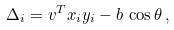<formula> <loc_0><loc_0><loc_500><loc_500>\Delta _ { i } = v ^ { T } x _ { i } y _ { i } - b \, \cos \theta \, ,</formula> 